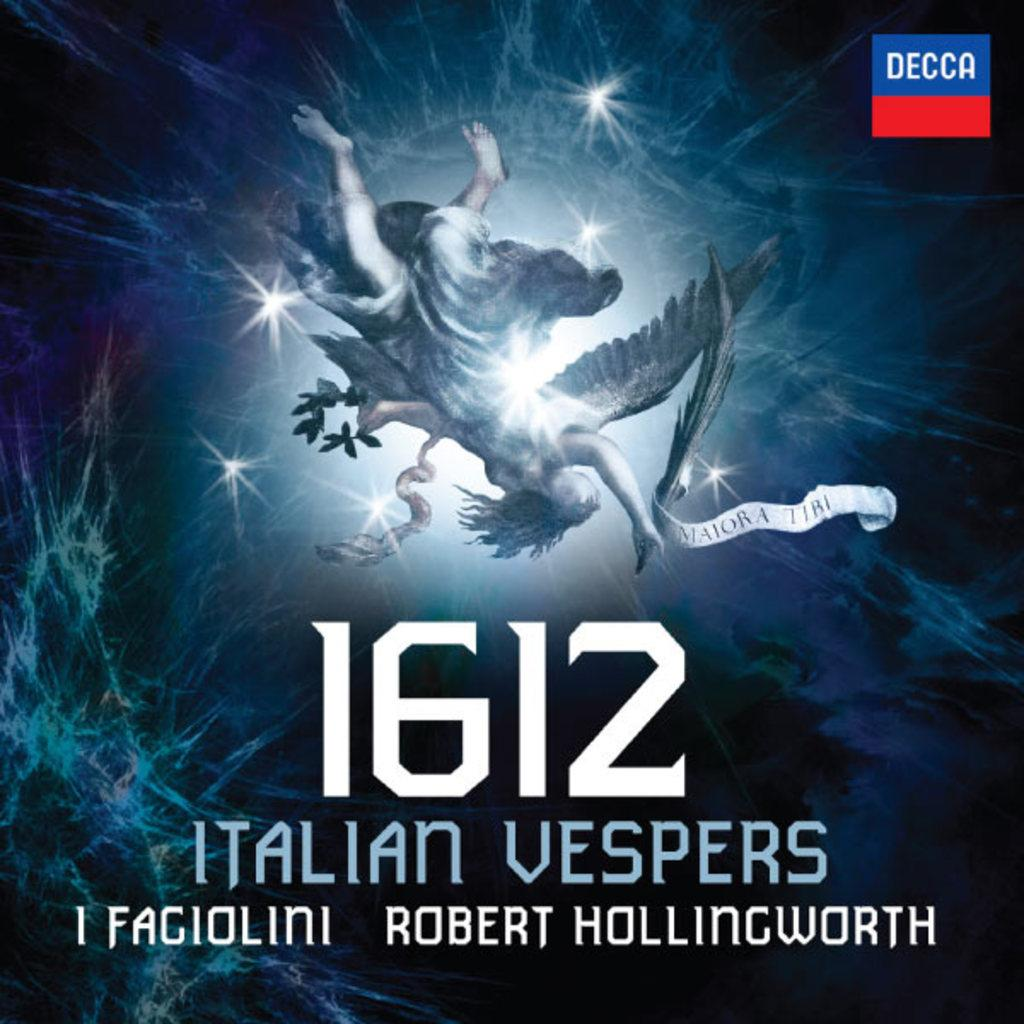<image>
Render a clear and concise summary of the photo. An angel type person on the cover of "1612 Italian Vespers". 